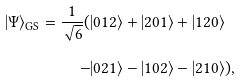<formula> <loc_0><loc_0><loc_500><loc_500>| \Psi \rangle _ { \text {GS} } = \frac { 1 } { \sqrt { 6 } } ( & | 0 1 2 \rangle + | 2 0 1 \rangle + | 1 2 0 \rangle \\ - & | 0 2 1 \rangle - | 1 0 2 \rangle - | 2 1 0 \rangle ) ,</formula> 